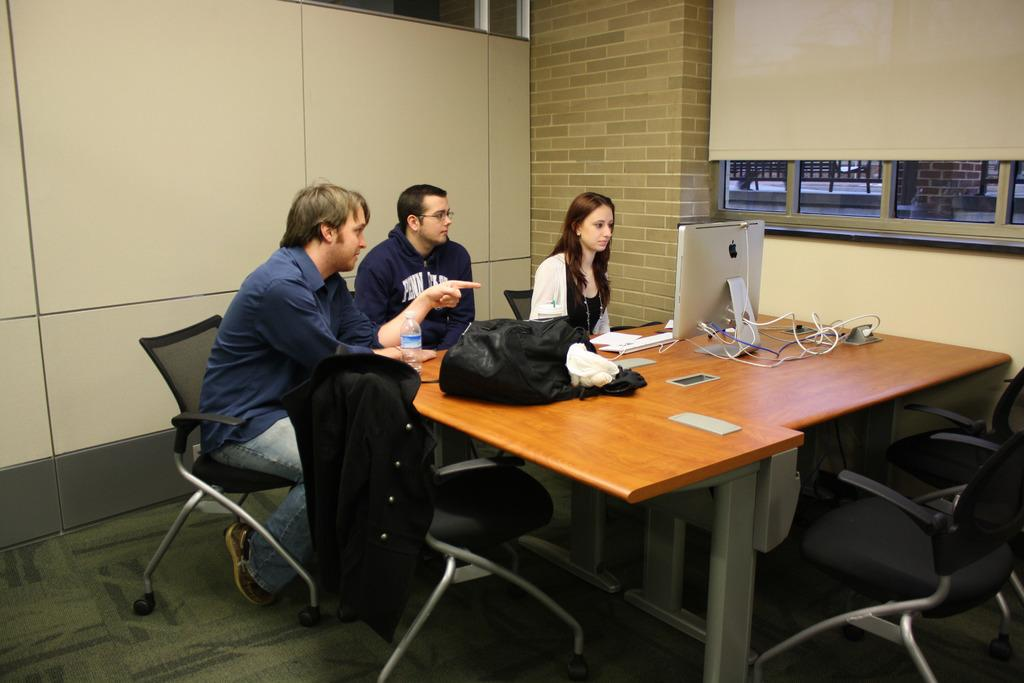How many people are sitting on the chair in the image? There are three persons sitting on a chair in the image. What is located near the chair in the image? There is a table in the image. What can be seen on the table? A system and a water bottle are present on the table. How many balls are visible on the table in the image? There are no balls visible on the table in the image. What type of machine is present on the table in the image? The provided facts do not mention a machine on the table; only a system is mentioned. 